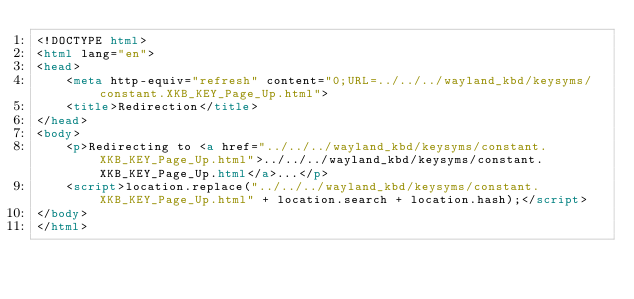<code> <loc_0><loc_0><loc_500><loc_500><_HTML_><!DOCTYPE html>
<html lang="en">
<head>
    <meta http-equiv="refresh" content="0;URL=../../../wayland_kbd/keysyms/constant.XKB_KEY_Page_Up.html">
    <title>Redirection</title>
</head>
<body>
    <p>Redirecting to <a href="../../../wayland_kbd/keysyms/constant.XKB_KEY_Page_Up.html">../../../wayland_kbd/keysyms/constant.XKB_KEY_Page_Up.html</a>...</p>
    <script>location.replace("../../../wayland_kbd/keysyms/constant.XKB_KEY_Page_Up.html" + location.search + location.hash);</script>
</body>
</html></code> 